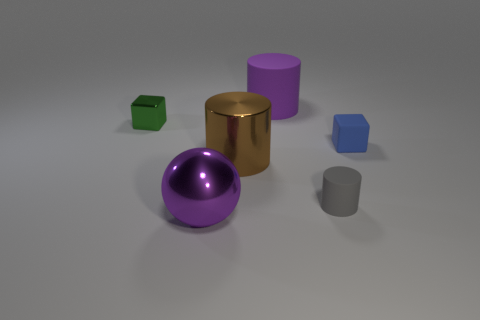Subtract all rubber cylinders. How many cylinders are left? 1 Subtract 1 blocks. How many blocks are left? 1 Add 1 purple metal spheres. How many objects exist? 7 Subtract all brown cylinders. How many cylinders are left? 2 Subtract 0 cyan cubes. How many objects are left? 6 Subtract all cubes. How many objects are left? 4 Subtract all yellow cylinders. Subtract all yellow cubes. How many cylinders are left? 3 Subtract all cyan spheres. How many blue cubes are left? 1 Subtract all big brown metal objects. Subtract all small blue matte cubes. How many objects are left? 4 Add 5 large shiny cylinders. How many large shiny cylinders are left? 6 